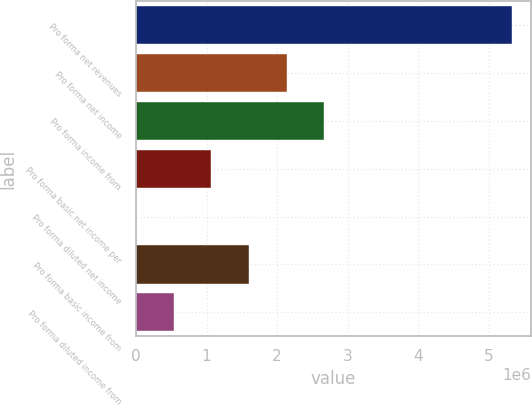Convert chart to OTSL. <chart><loc_0><loc_0><loc_500><loc_500><bar_chart><fcel>Pro forma net revenues<fcel>Pro forma net income<fcel>Pro forma income from<fcel>Pro forma basic net income per<fcel>Pro forma diluted net income<fcel>Pro forma basic income from<fcel>Pro forma diluted income from<nl><fcel>5.33359e+06<fcel>2.13344e+06<fcel>2.6668e+06<fcel>1.06672e+06<fcel>3.65<fcel>1.60008e+06<fcel>533362<nl></chart> 